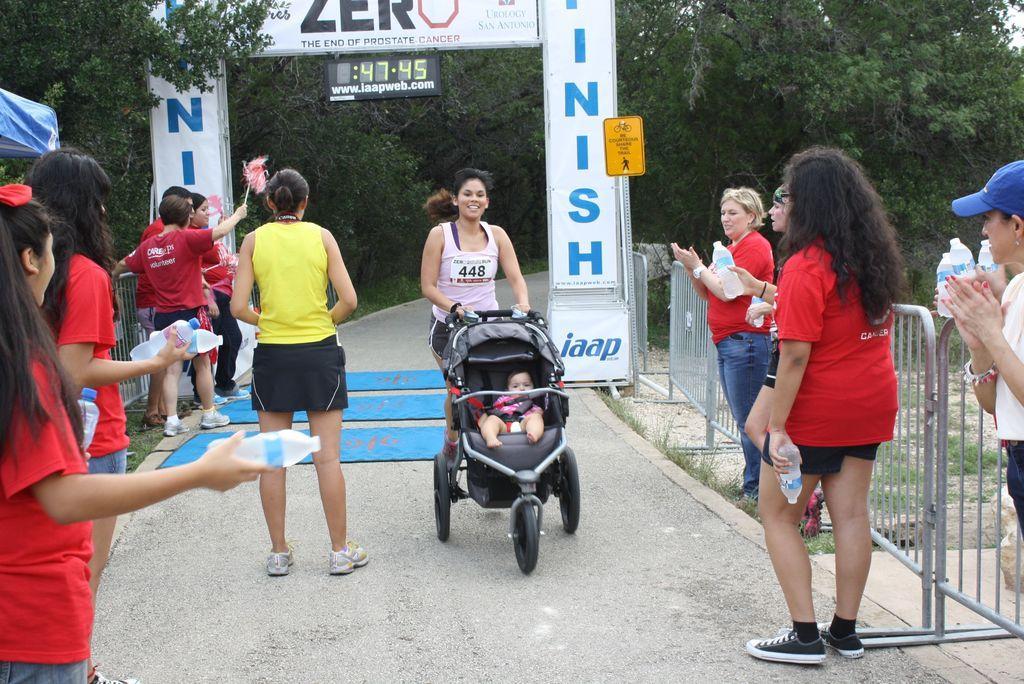How would you summarize this image in a sentence or two? In this picture, we see a woman is pushing the baby stroller. She is smiling. Beside her, we see a woman in the yellow T-shirt is standing. On either side of the picture, we see the women are standing and most of them are holding the water bottles in their hands. Behind them, we see the road railings. On the left side, we see a blue color tint. On the right side, we see a pole and a board in yellow color with some text written on it. In the middle, we see a board in white color with some text written on it. There are trees in the background. At the bottom, we see the road and the carpets in blue color. 